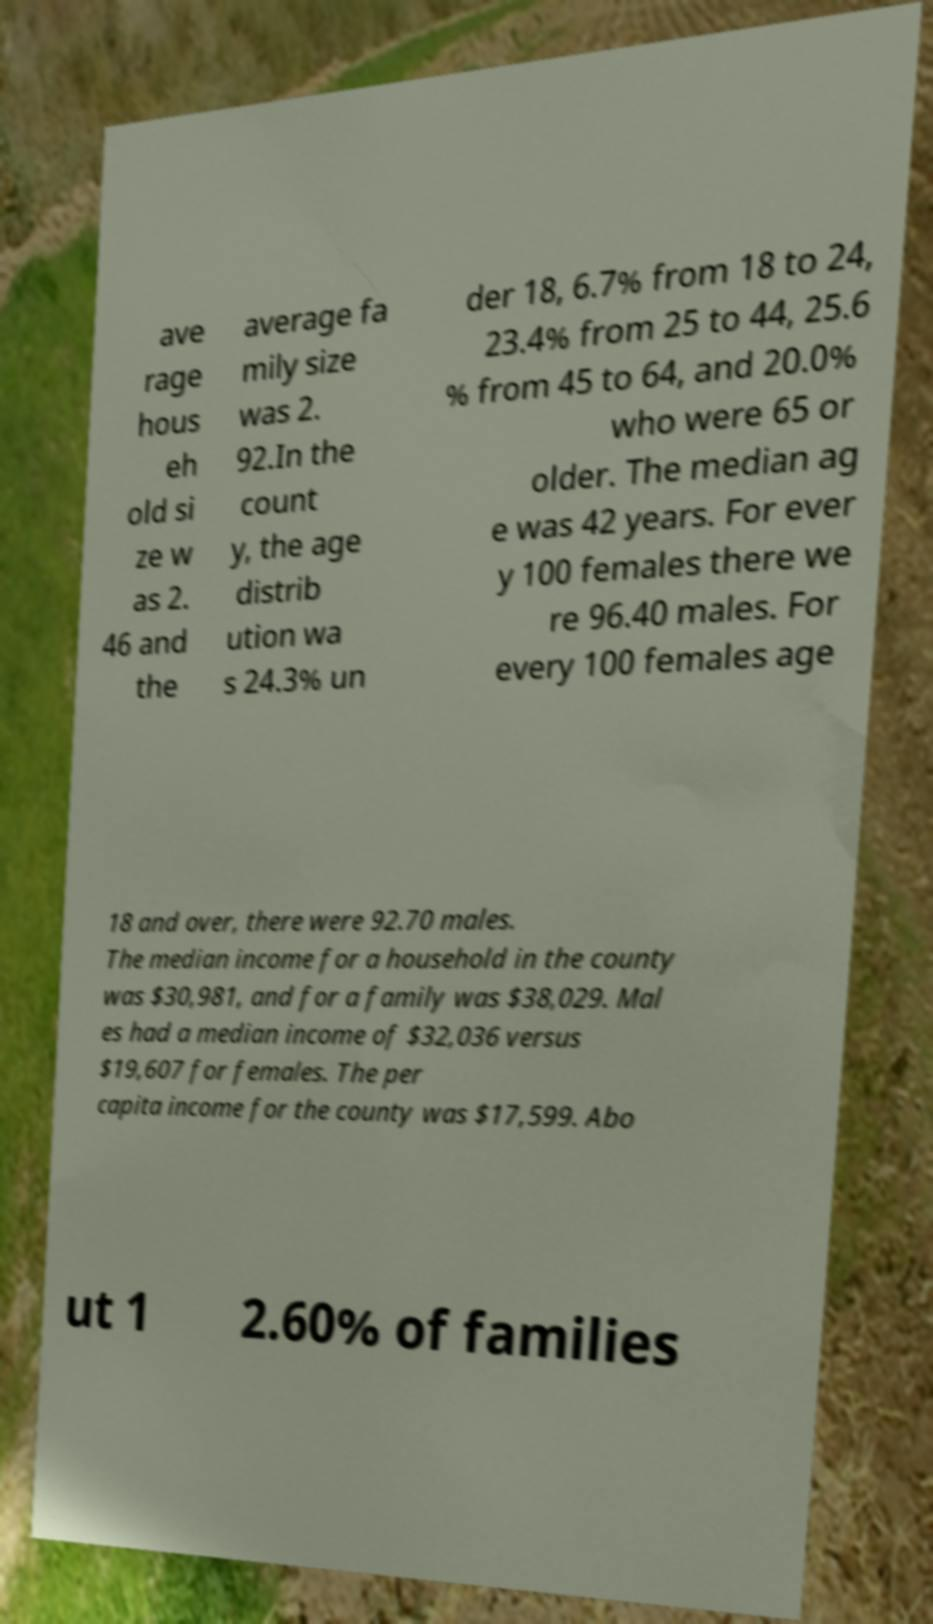I need the written content from this picture converted into text. Can you do that? ave rage hous eh old si ze w as 2. 46 and the average fa mily size was 2. 92.In the count y, the age distrib ution wa s 24.3% un der 18, 6.7% from 18 to 24, 23.4% from 25 to 44, 25.6 % from 45 to 64, and 20.0% who were 65 or older. The median ag e was 42 years. For ever y 100 females there we re 96.40 males. For every 100 females age 18 and over, there were 92.70 males. The median income for a household in the county was $30,981, and for a family was $38,029. Mal es had a median income of $32,036 versus $19,607 for females. The per capita income for the county was $17,599. Abo ut 1 2.60% of families 